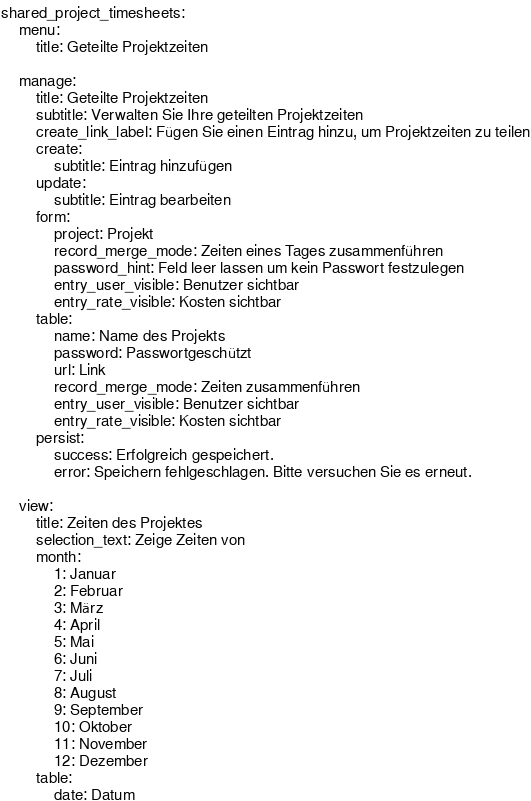<code> <loc_0><loc_0><loc_500><loc_500><_YAML_>shared_project_timesheets:
    menu:
        title: Geteilte Projektzeiten

    manage:
        title: Geteilte Projektzeiten
        subtitle: Verwalten Sie Ihre geteilten Projektzeiten
        create_link_label: Fügen Sie einen Eintrag hinzu, um Projektzeiten zu teilen
        create:
            subtitle: Eintrag hinzufügen
        update:
            subtitle: Eintrag bearbeiten
        form:
            project: Projekt
            record_merge_mode: Zeiten eines Tages zusammenführen
            password_hint: Feld leer lassen um kein Passwort festzulegen
            entry_user_visible: Benutzer sichtbar
            entry_rate_visible: Kosten sichtbar
        table:
            name: Name des Projekts
            password: Passwortgeschützt
            url: Link
            record_merge_mode: Zeiten zusammenführen
            entry_user_visible: Benutzer sichtbar
            entry_rate_visible: Kosten sichtbar
        persist:
            success: Erfolgreich gespeichert.
            error: Speichern fehlgeschlagen. Bitte versuchen Sie es erneut.

    view:
        title: Zeiten des Projektes
        selection_text: Zeige Zeiten von
        month:
            1: Januar
            2: Februar
            3: März
            4: April
            5: Mai
            6: Juni
            7: Juli
            8: August
            9: September
            10: Oktober
            11: November
            12: Dezember
        table:
            date: Datum</code> 